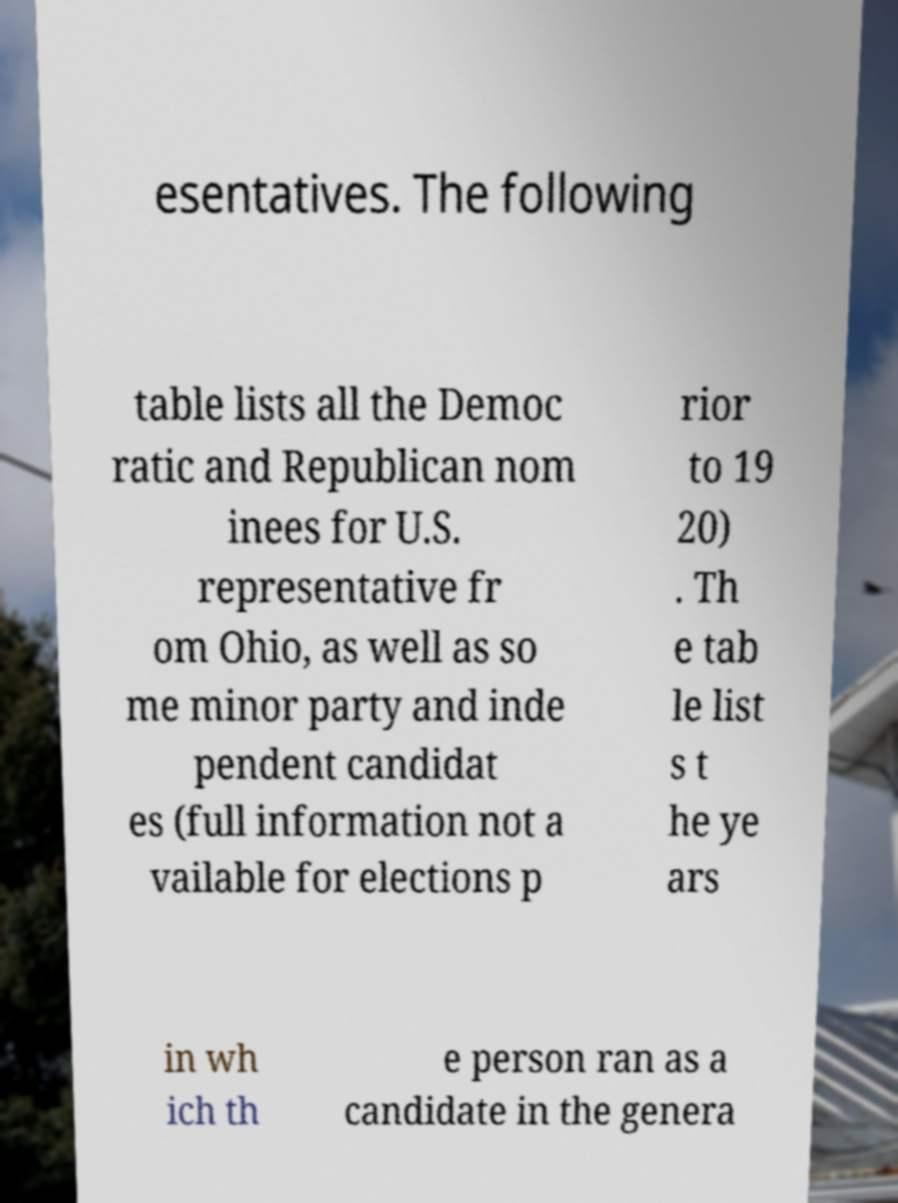Could you assist in decoding the text presented in this image and type it out clearly? esentatives. The following table lists all the Democ ratic and Republican nom inees for U.S. representative fr om Ohio, as well as so me minor party and inde pendent candidat es (full information not a vailable for elections p rior to 19 20) . Th e tab le list s t he ye ars in wh ich th e person ran as a candidate in the genera 